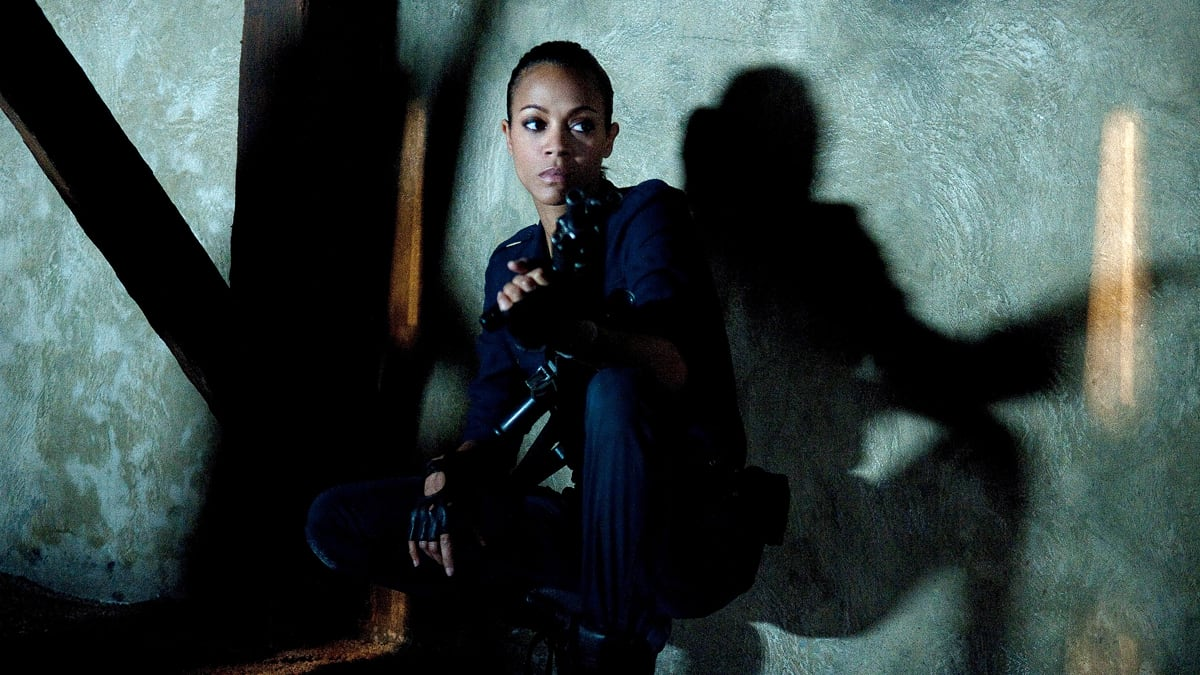What do you think is going on in this snapshot? The image depicts a woman in a tense situation, portrayed in a dimly lit room. She is crouched low, her body poised for action, shadows cascading behind her due to a single light source. Clad in a dark outfit which merges seamlessly with the shadows, she grips a firearm, indicating readiness for a potential threat. Her expression is stern, eyes sharply focused, encapsulating the gravity of her circumstances. 